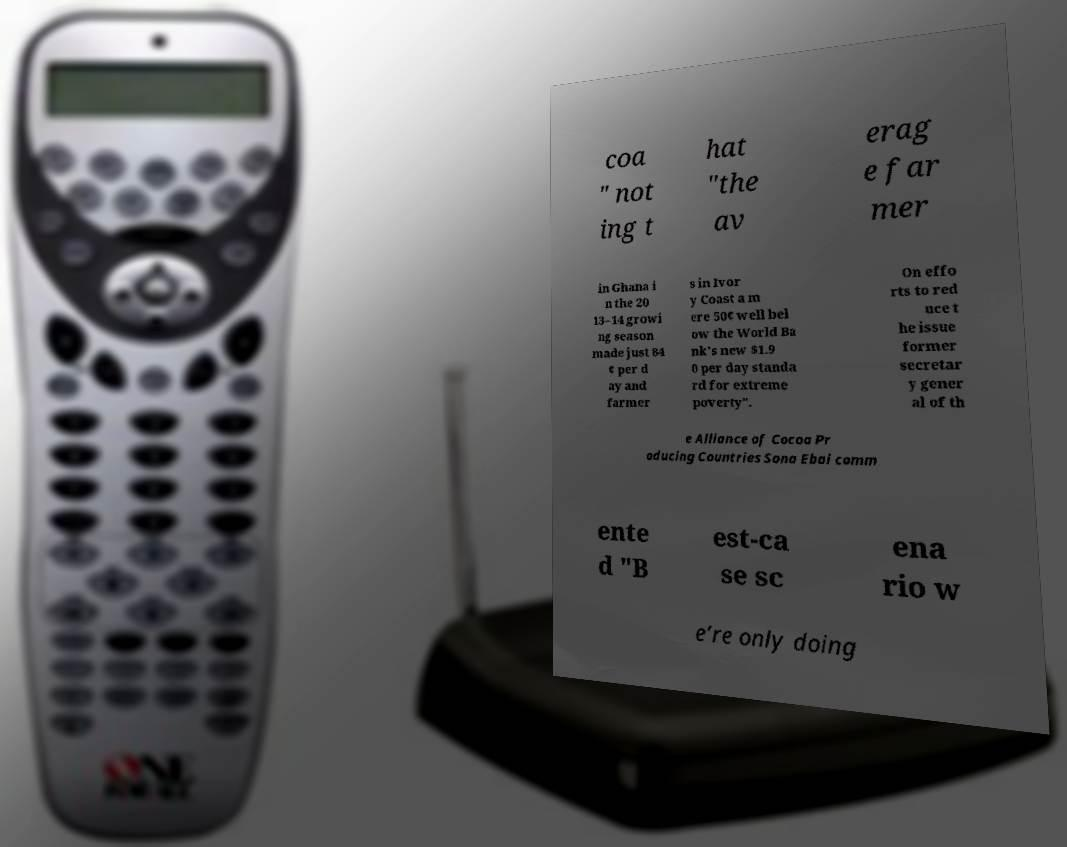Can you read and provide the text displayed in the image?This photo seems to have some interesting text. Can you extract and type it out for me? coa " not ing t hat "the av erag e far mer in Ghana i n the 20 13–14 growi ng season made just 84 ¢ per d ay and farmer s in Ivor y Coast a m ere 50¢ well bel ow the World Ba nk's new $1.9 0 per day standa rd for extreme poverty". On effo rts to red uce t he issue former secretar y gener al of th e Alliance of Cocoa Pr oducing Countries Sona Ebai comm ente d "B est-ca se sc ena rio w e’re only doing 